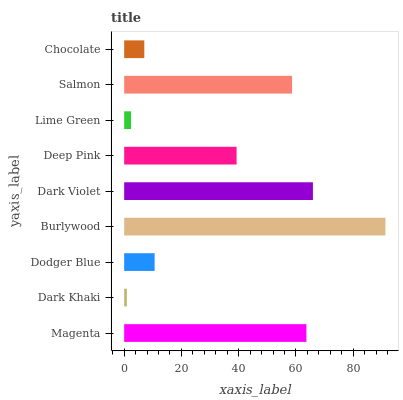Is Dark Khaki the minimum?
Answer yes or no. Yes. Is Burlywood the maximum?
Answer yes or no. Yes. Is Dodger Blue the minimum?
Answer yes or no. No. Is Dodger Blue the maximum?
Answer yes or no. No. Is Dodger Blue greater than Dark Khaki?
Answer yes or no. Yes. Is Dark Khaki less than Dodger Blue?
Answer yes or no. Yes. Is Dark Khaki greater than Dodger Blue?
Answer yes or no. No. Is Dodger Blue less than Dark Khaki?
Answer yes or no. No. Is Deep Pink the high median?
Answer yes or no. Yes. Is Deep Pink the low median?
Answer yes or no. Yes. Is Lime Green the high median?
Answer yes or no. No. Is Lime Green the low median?
Answer yes or no. No. 